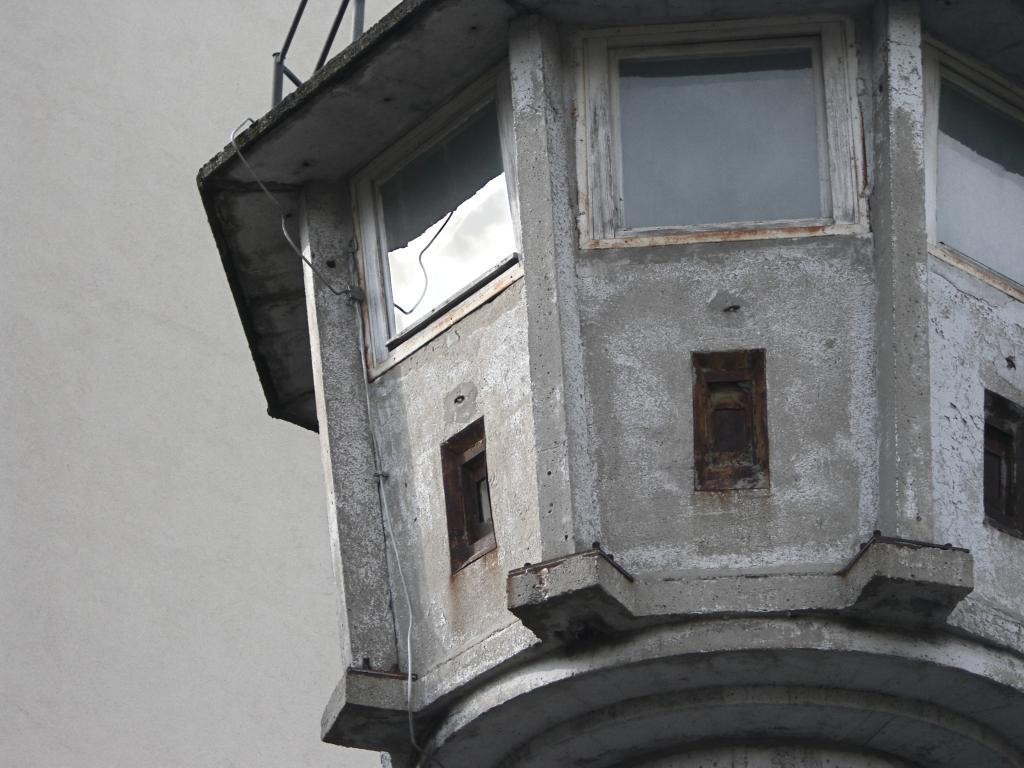What is the main structure visible in the image? There is a tower in the image. What color is the background on the left side of the image? The left side of the image has a grey color background. How many people are wearing scarves in the crowd near the tower in the image? There is no crowd or people wearing scarves present in the image; it only features a tower and a grey color background on the left side. 